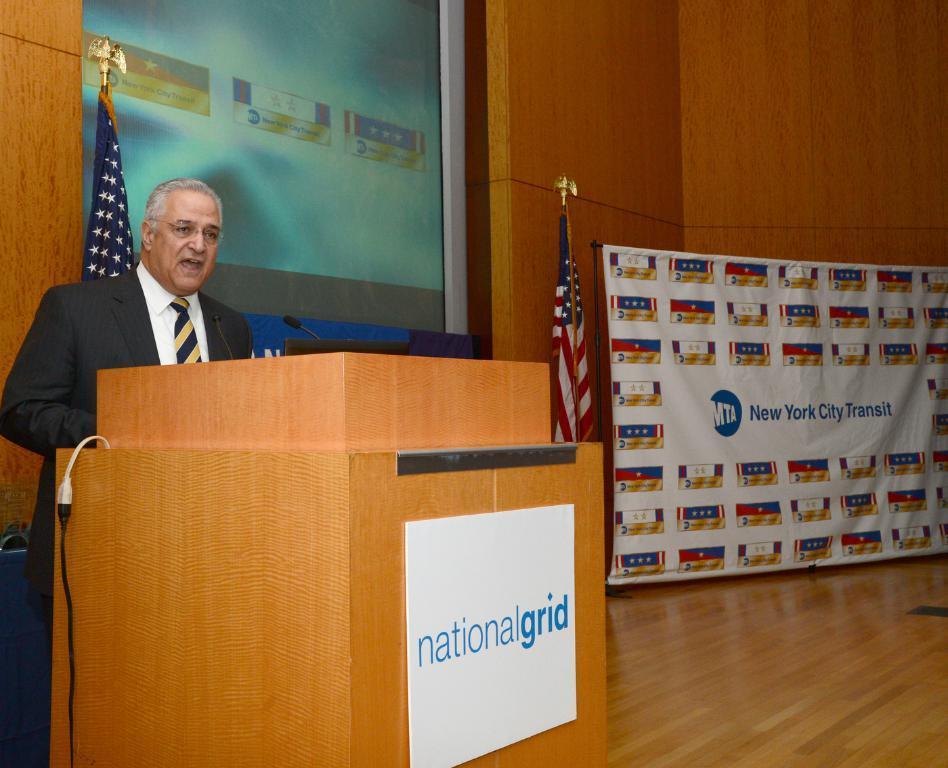Could you give a brief overview of what you see in this image? In this picture we can observe a person standing in front of a brown color podium wearing black color coat and speaking. There is a mic in front of him. We can observe two flags. On the right side there is a poster. There is a screen on the left side. In the background there is a wall which is in brown color. 